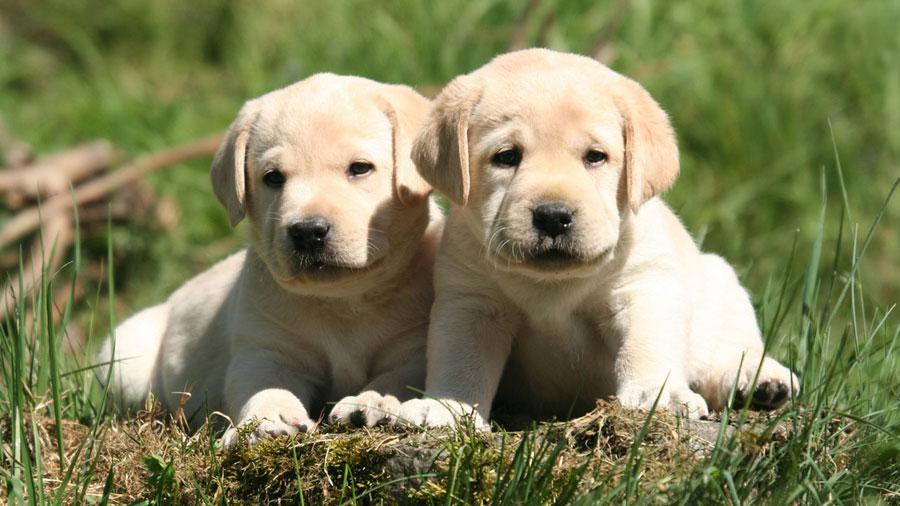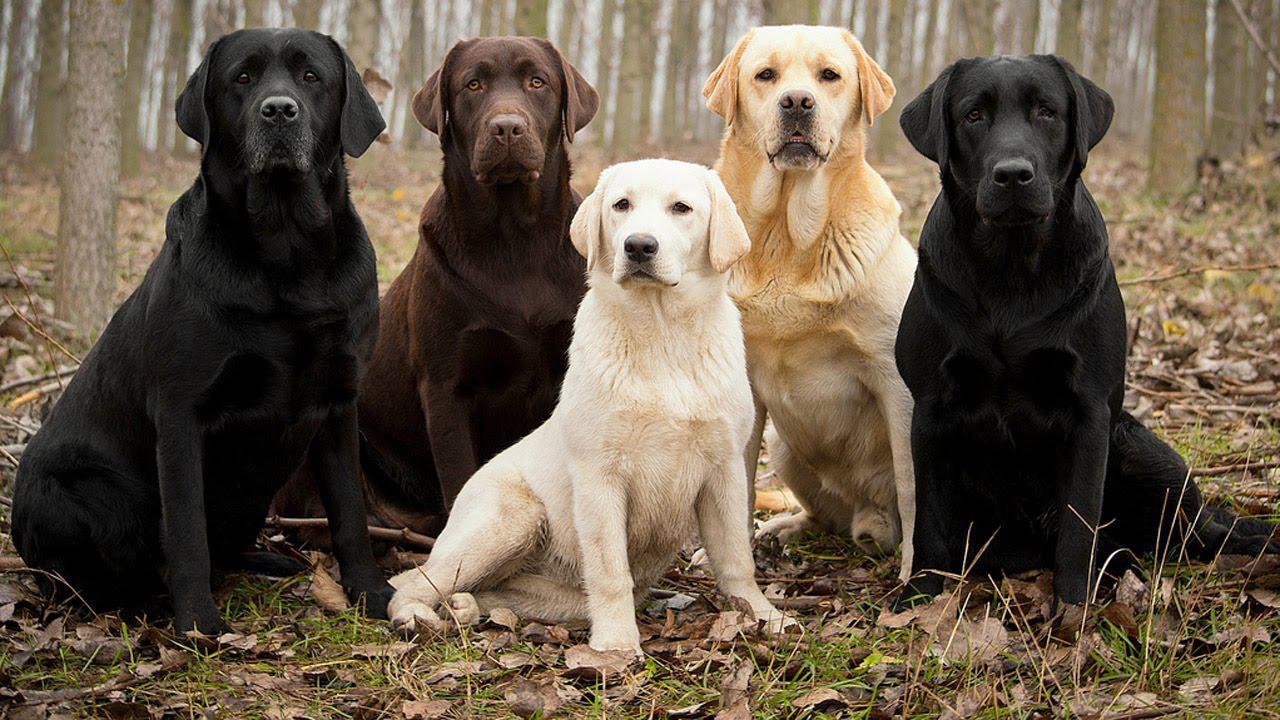The first image is the image on the left, the second image is the image on the right. For the images shown, is this caption "There are no more than four labrador retrievers" true? Answer yes or no. No. 